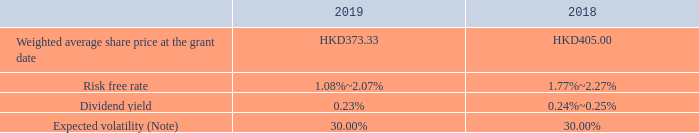SHARE-BASED PAYMENTS (continued)
(a) Share option schemes (continued) (iii) Fair value of option
The directors of the Company have used the Binomial Model to determine the fair value of the options as at the respective grant dates, which is to be expensed over the relevant vesting period. The weighted average fair value of options granted during the year ended 31 December 2019 was HKD123.82 per share (equivalent to approximately RMB106.09 per share) (2018: HKD127.43 per share (equivalent to approximately RMB103.46 per share)).
Other than the exercise price mentioned above, significant judgment on parameters, such as risk free rate, dividend yield and expected volatility, are required to be made by the directors in applying the Binomial Model, which are summarised as below.
Note: The expected volatility, measured as the standard deviation of expected share price returns, is determined based on the average daily trading price volatility of the shares of the Company.
How did the directors  determine the fair value of the options as at the respective grant dates? Binomial model. How much was the weighted average fair value per share of options granted during the year ended 31 December 2019 in RMB? Hkd123.82 per share (equivalent to approximately rmb106.09 per share). How much was the weighted average fair value per share of options granted during the year ended 31 December 2018 in RMB? Hkd127.43 per share (equivalent to approximately rmb103.46 per share). How much did the Weighted average share price at the grant date change by between 2018 and 2019? 373.33-405.00
Answer: -31.67. How much did the Expected volatility change by between 2018 and 2019?
Answer scale should be: percent. 30.00%-30.00%
Answer: 0. How much did the weighted average fair value per share of options granted change by in RMB between 2018 and 2019 year end?  106.09-103.46
Answer: 2.63. 